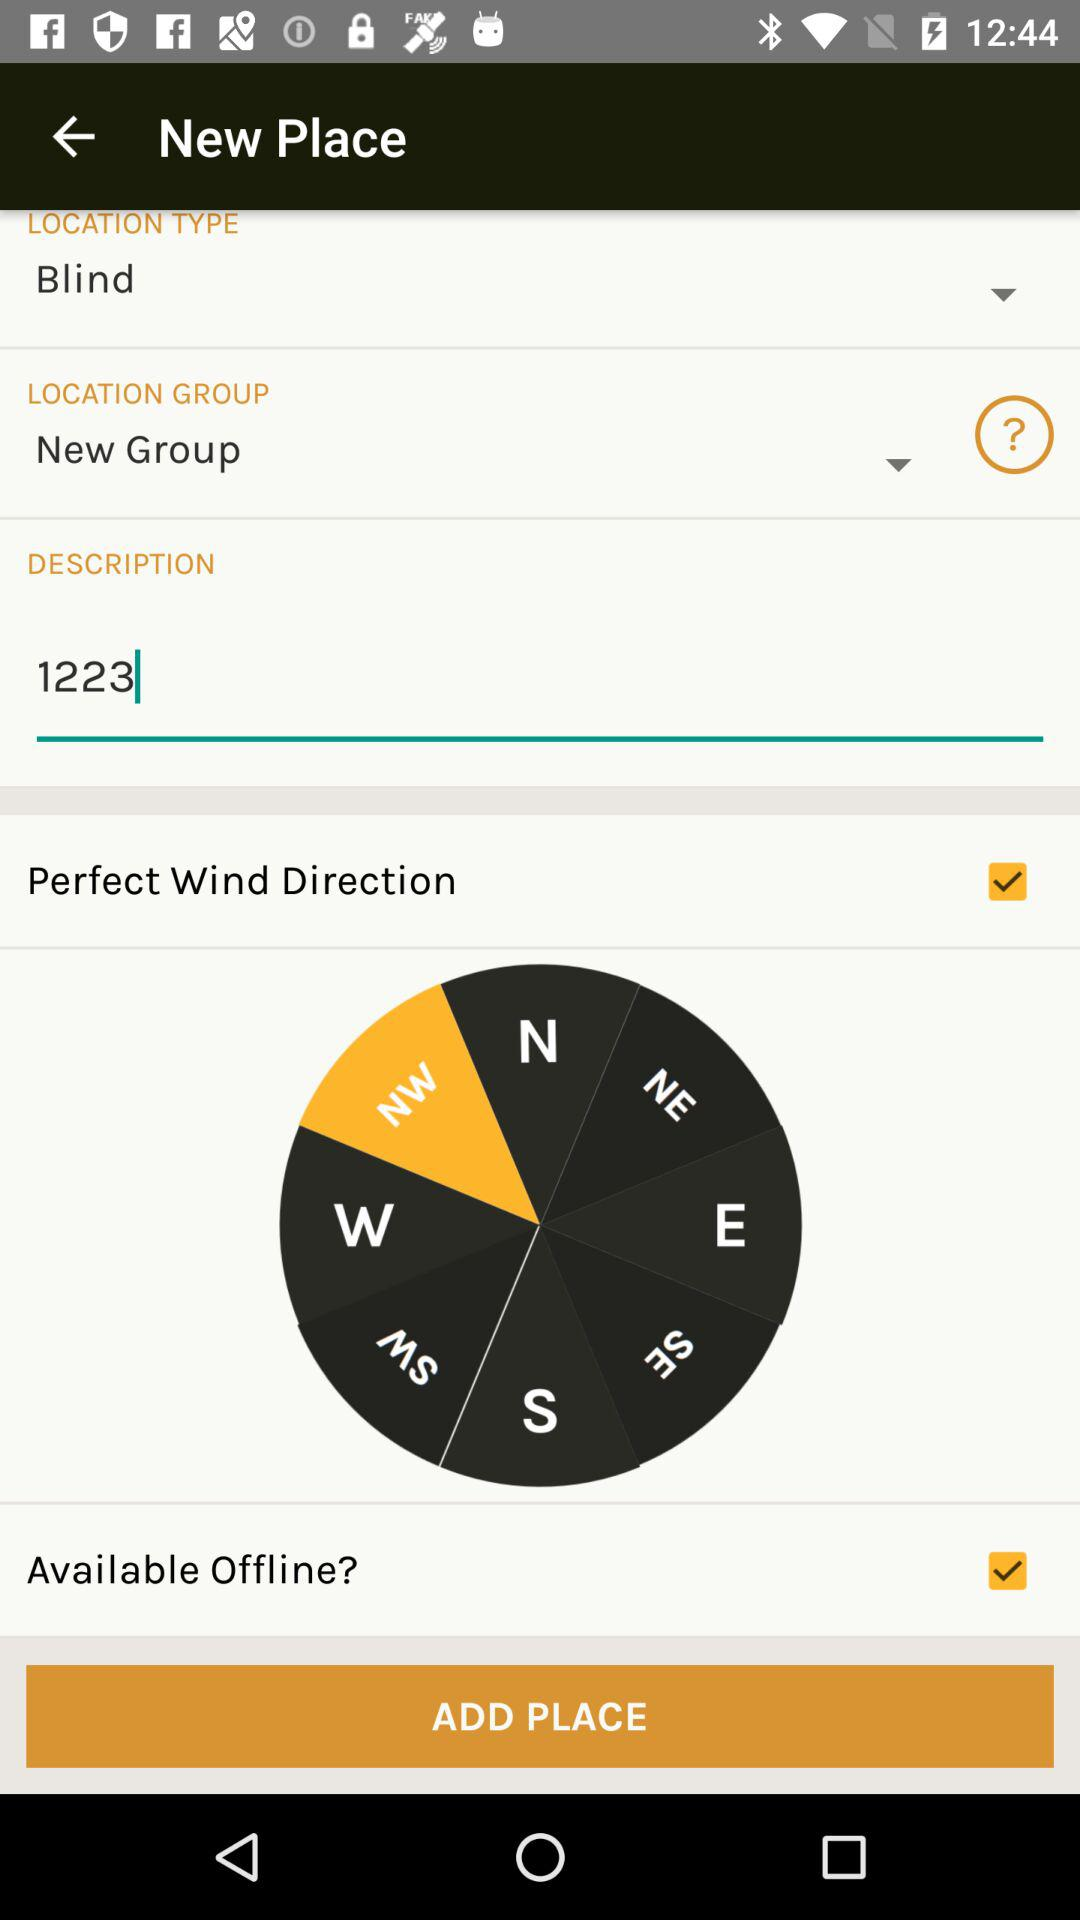How many check boxes are there?
Answer the question using a single word or phrase. 2 